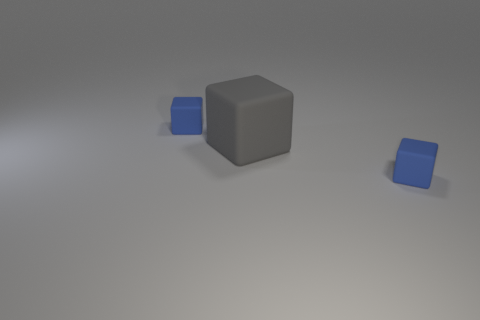How many shiny objects are large things or small yellow objects?
Make the answer very short. 0. What material is the blue cube to the right of the tiny blue matte block that is behind the small rubber thing that is right of the big cube?
Ensure brevity in your answer.  Rubber. There is a small blue thing behind the big gray rubber cube; does it have the same shape as the small object in front of the large matte thing?
Ensure brevity in your answer.  Yes. What is the color of the small rubber block that is right of the matte cube on the left side of the large gray cube?
Your response must be concise. Blue. How many blocks are rubber things or large gray matte objects?
Keep it short and to the point. 3. What number of large gray rubber objects are to the right of the tiny thing left of the rubber thing in front of the gray object?
Provide a succinct answer. 1. Are there any tiny blue cubes made of the same material as the gray block?
Keep it short and to the point. Yes. What number of gray matte things are behind the blue thing to the left of the gray block?
Offer a terse response. 0. What number of gray objects are either large cubes or tiny matte cubes?
Give a very brief answer. 1. What shape is the tiny blue rubber object to the left of the small blue block that is to the right of the rubber block on the left side of the big gray rubber block?
Ensure brevity in your answer.  Cube. 